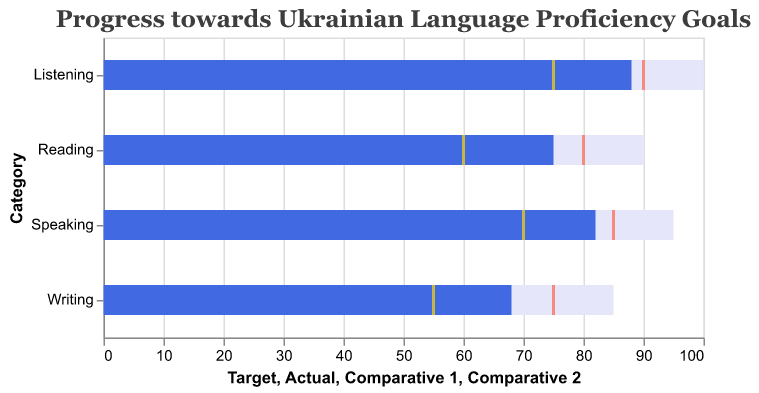What is the title of the chart? The title is shown at the top of the chart.
Answer: Progress towards Ukrainian Language Proficiency Goals Which skill has the highest actual value? By observing the bars representing actual values, listening has the highest bar.
Answer: Listening How does the actual value of reading compare to its target? The bar representing the actual value for reading is shorter than the bar representing its target. The actual value is 75, and the target is 90.
Answer: The actual value is 15 less than the target What is the average target value across the four skills? Add the target values for reading, writing, speaking, and listening (90 + 85 + 95 + 100) and divide by 4.
Answer: 92.5 Which skills have an actual value that is greater than the comparative value 1? Identify the skills where the actual value bar is further to the right than the tick mark for comparative value 1.
Answer: Reading, Writing, Speaking, Listening Is the actual value for writing closer to comparative value 1 or comparative value 2? Compare the distance between the actual value bar and the respective tick marks for comparative values 1 (55) and 2 (75); the actual value is 68.
Answer: Comparative value 2 What is the difference between the highest and lowest comparative value 2? The comparative value 2 values are 80 for reading, 75 for writing, 85 for speaking, and 90 for listening. Subtract the lowest (75) from the highest (90).
Answer: 15 What skill has the smallest gap between actual and target values? Calculate the difference between actual and target values for each skill and find the smallest.
Answer: Listening Which skill needs the most improvement to meet the target? Identify the skill with the largest difference between its actual and target values.
Answer: Speaking 